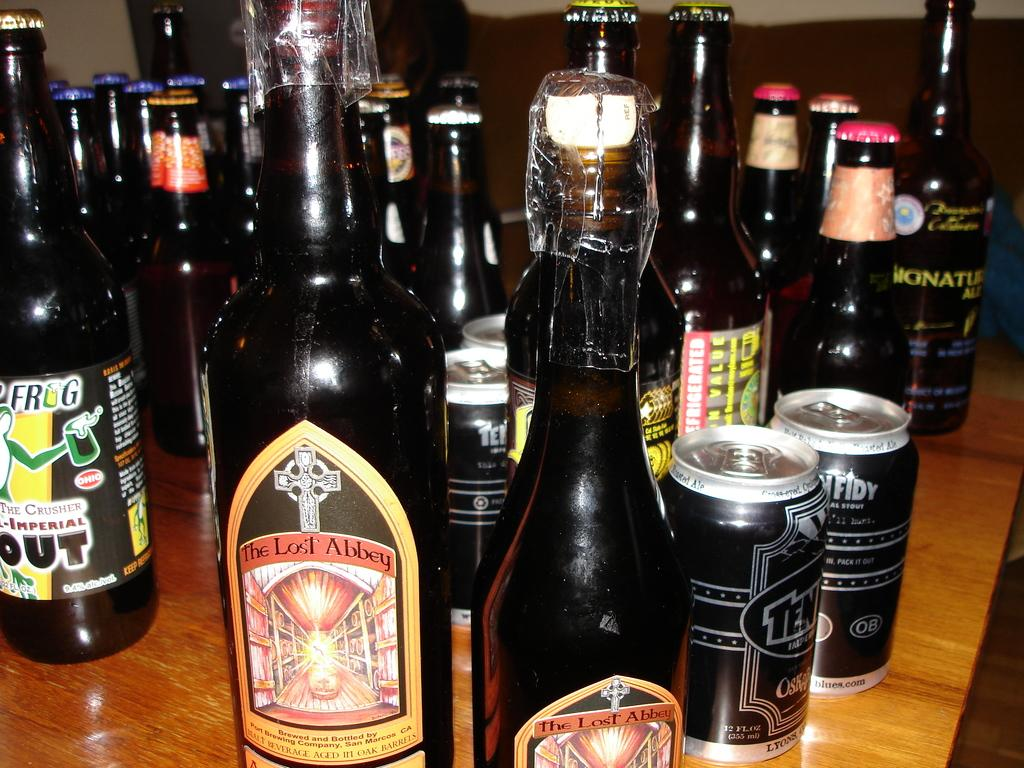<image>
Describe the image concisely. Many bottles of beer are arranged on a shelf including one named The Lost Abbey. 